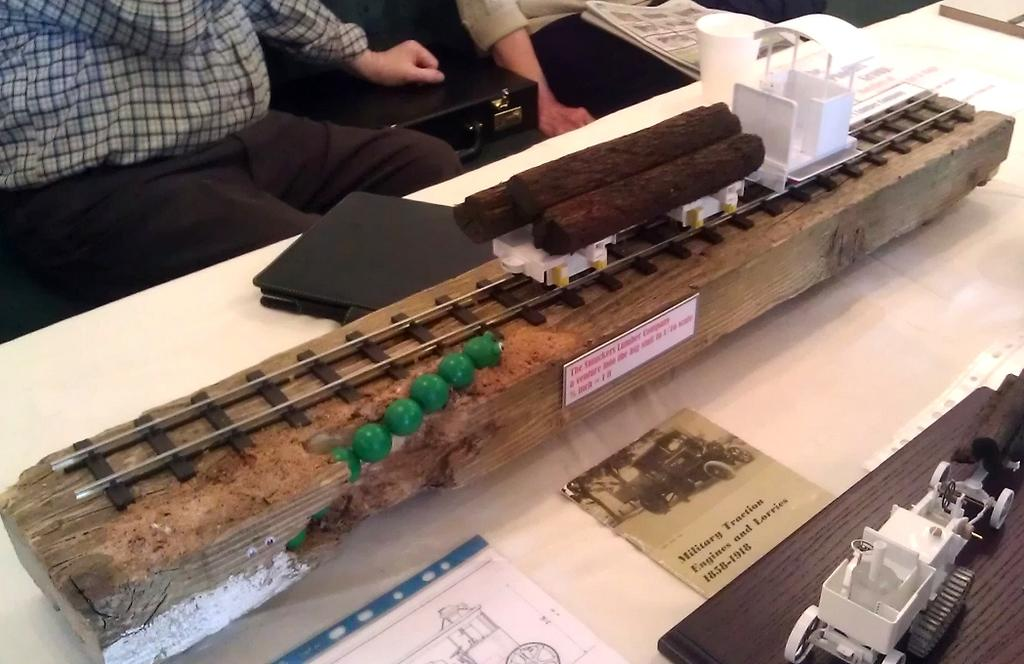What is on the table in the image? There is a bamboo stick and papers on the table. Are there any other objects on the table? Yes, there are other objects on the table. What is the person in the image doing? The person is sitting in front of the table. What can be seen beside the table? There is a briefcase beside the table. What type of comfort can be seen in the image? There is no specific comfort item visible in the image. Can you hear a bell ringing in the image? There is no bell present in the image, so it cannot be heard. 